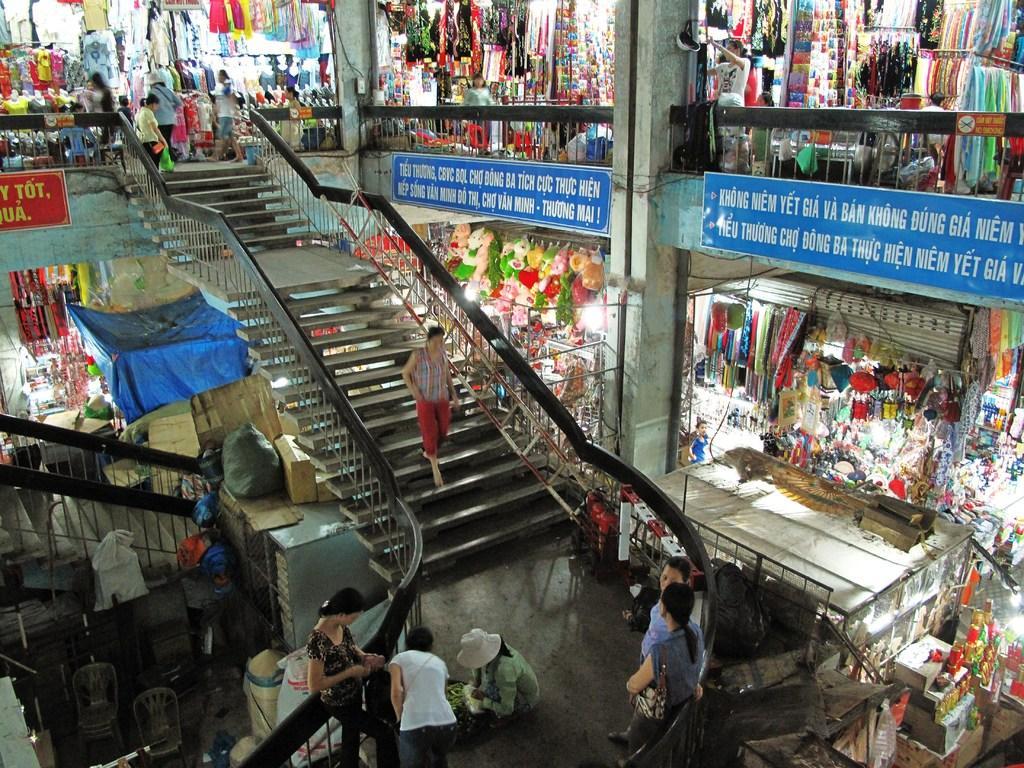Describe this image in one or two sentences. In this picture we can see stores, teddies, boards, cardboard boxes, people, steps, chairs, railings, pillars and things. Those are sign boards. 